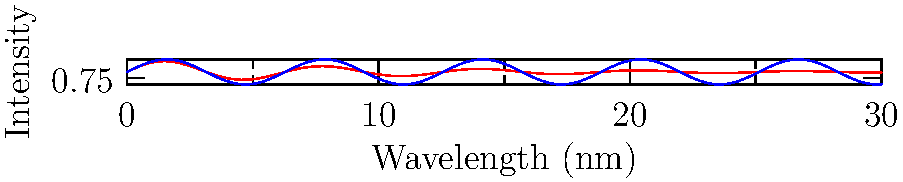Based on the electromagnetic spectrum diagram, which UV range is most effective for sterilization in medical settings, and why is this knowledge crucial for a general practitioner managing infection control during the COVID-19 pandemic? 1. The diagram shows the electromagnetic spectrum focusing on the ultraviolet (UV) and visible light ranges.

2. The red curve represents the sterilization effectiveness, while the blue curve represents the intensity of radiation.

3. UV light is divided into three main categories:
   - UV-C (100-280 nm)
   - UV-B (280-315 nm)
   - UV-A (315-400 nm)

4. Observing the red curve (sterilization effectiveness):
   - It peaks in the UV-C range
   - It decreases significantly in the UV-B and UV-A ranges

5. UV-C is most effective for sterilization because:
   - It has the highest energy photons in the UV spectrum
   - It can effectively damage the DNA and RNA of microorganisms, including viruses

6. For a general practitioner during the COVID-19 pandemic:
   - Understanding UV sterilization is crucial for implementing effective infection control measures
   - It helps in selecting appropriate UV sterilization equipment for medical settings
   - It aids in educating staff and patients about proper disinfection techniques
   - It ensures the safe and effective use of UV sterilization to reduce the spread of SARS-CoV-2 and other pathogens

7. However, it's important to note that UV-C can be harmful to human skin and eyes, so proper safety precautions must be taken when using UV-C sterilization devices.
Answer: UV-C is most effective for sterilization, crucial for efficient infection control in medical settings during the COVID-19 pandemic. 